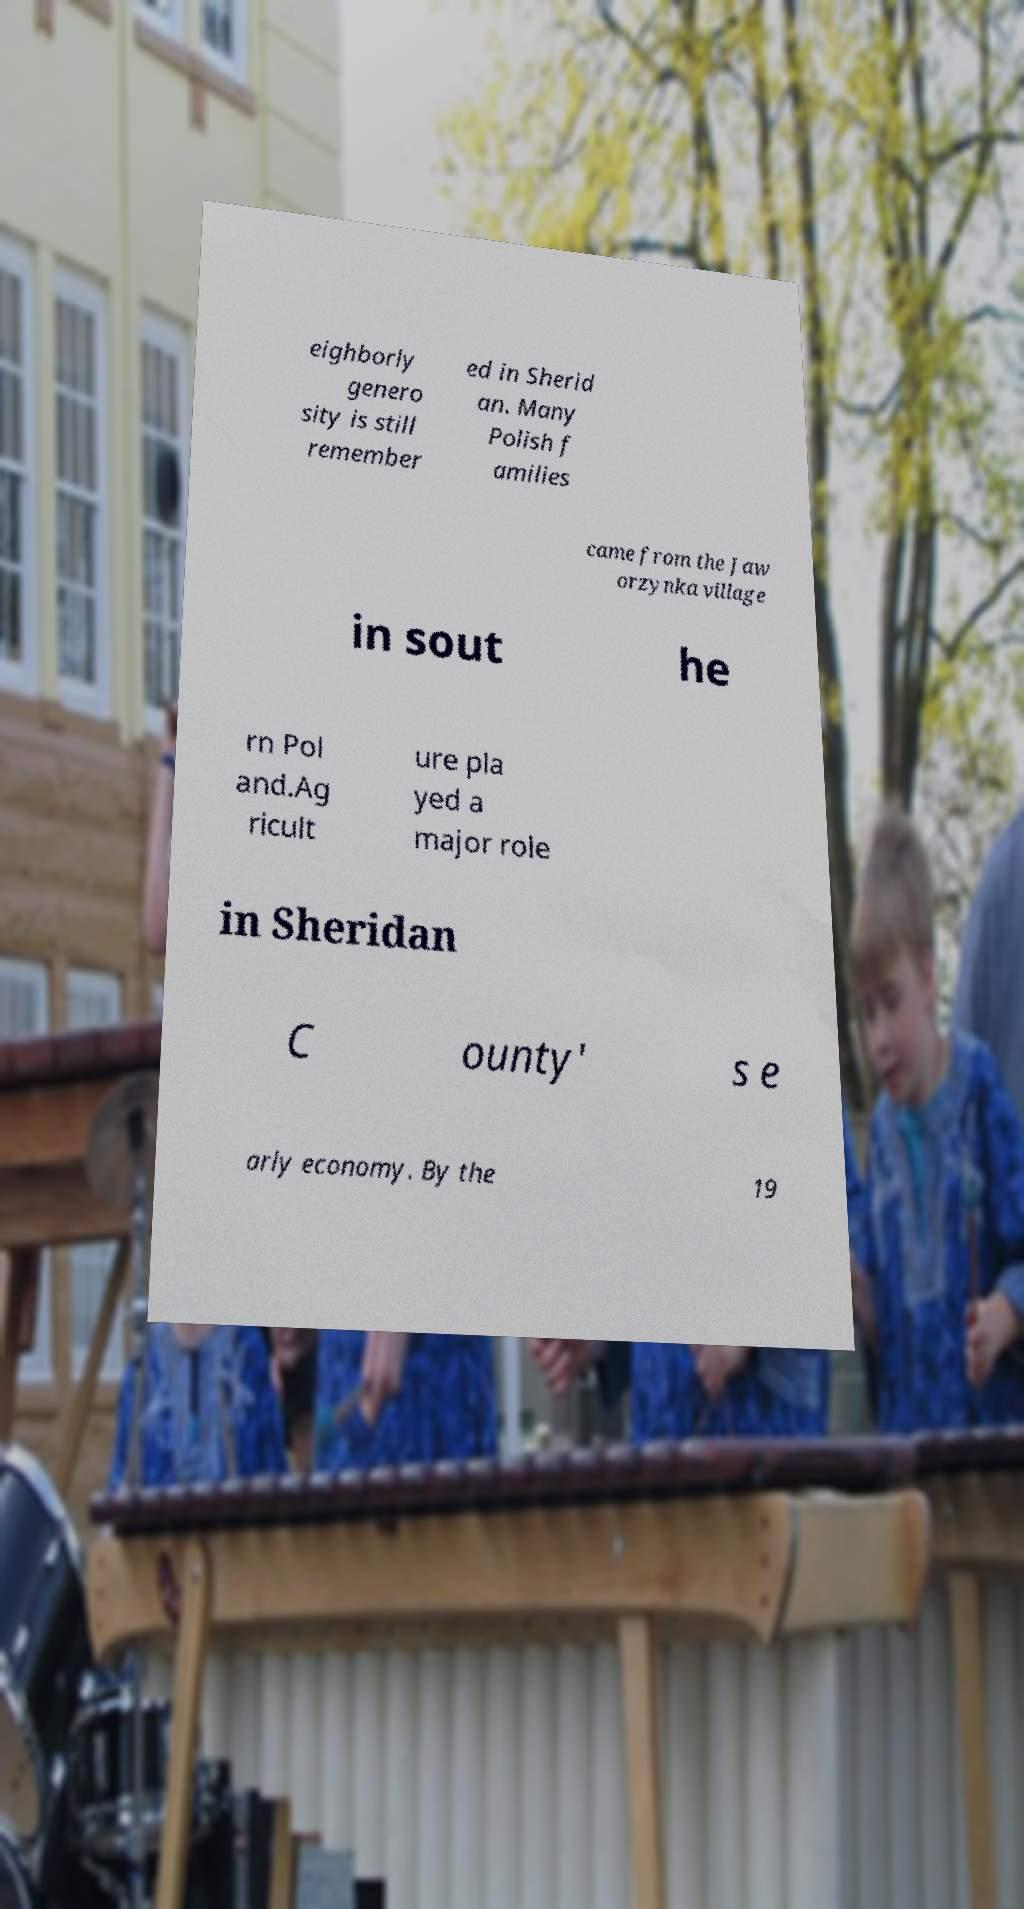Could you extract and type out the text from this image? eighborly genero sity is still remember ed in Sherid an. Many Polish f amilies came from the Jaw orzynka village in sout he rn Pol and.Ag ricult ure pla yed a major role in Sheridan C ounty' s e arly economy. By the 19 